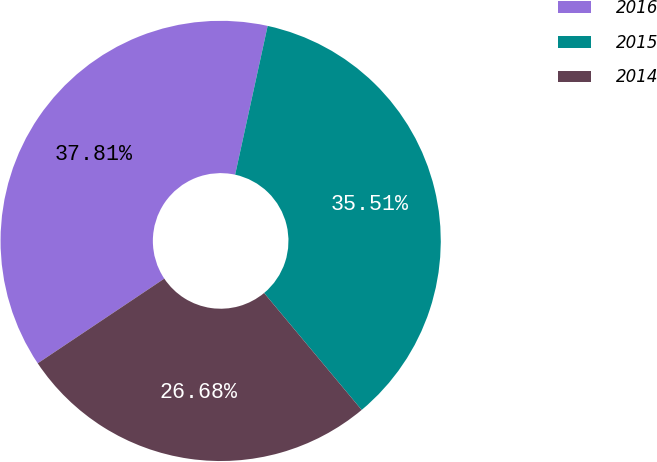<chart> <loc_0><loc_0><loc_500><loc_500><pie_chart><fcel>2016<fcel>2015<fcel>2014<nl><fcel>37.81%<fcel>35.51%<fcel>26.68%<nl></chart> 